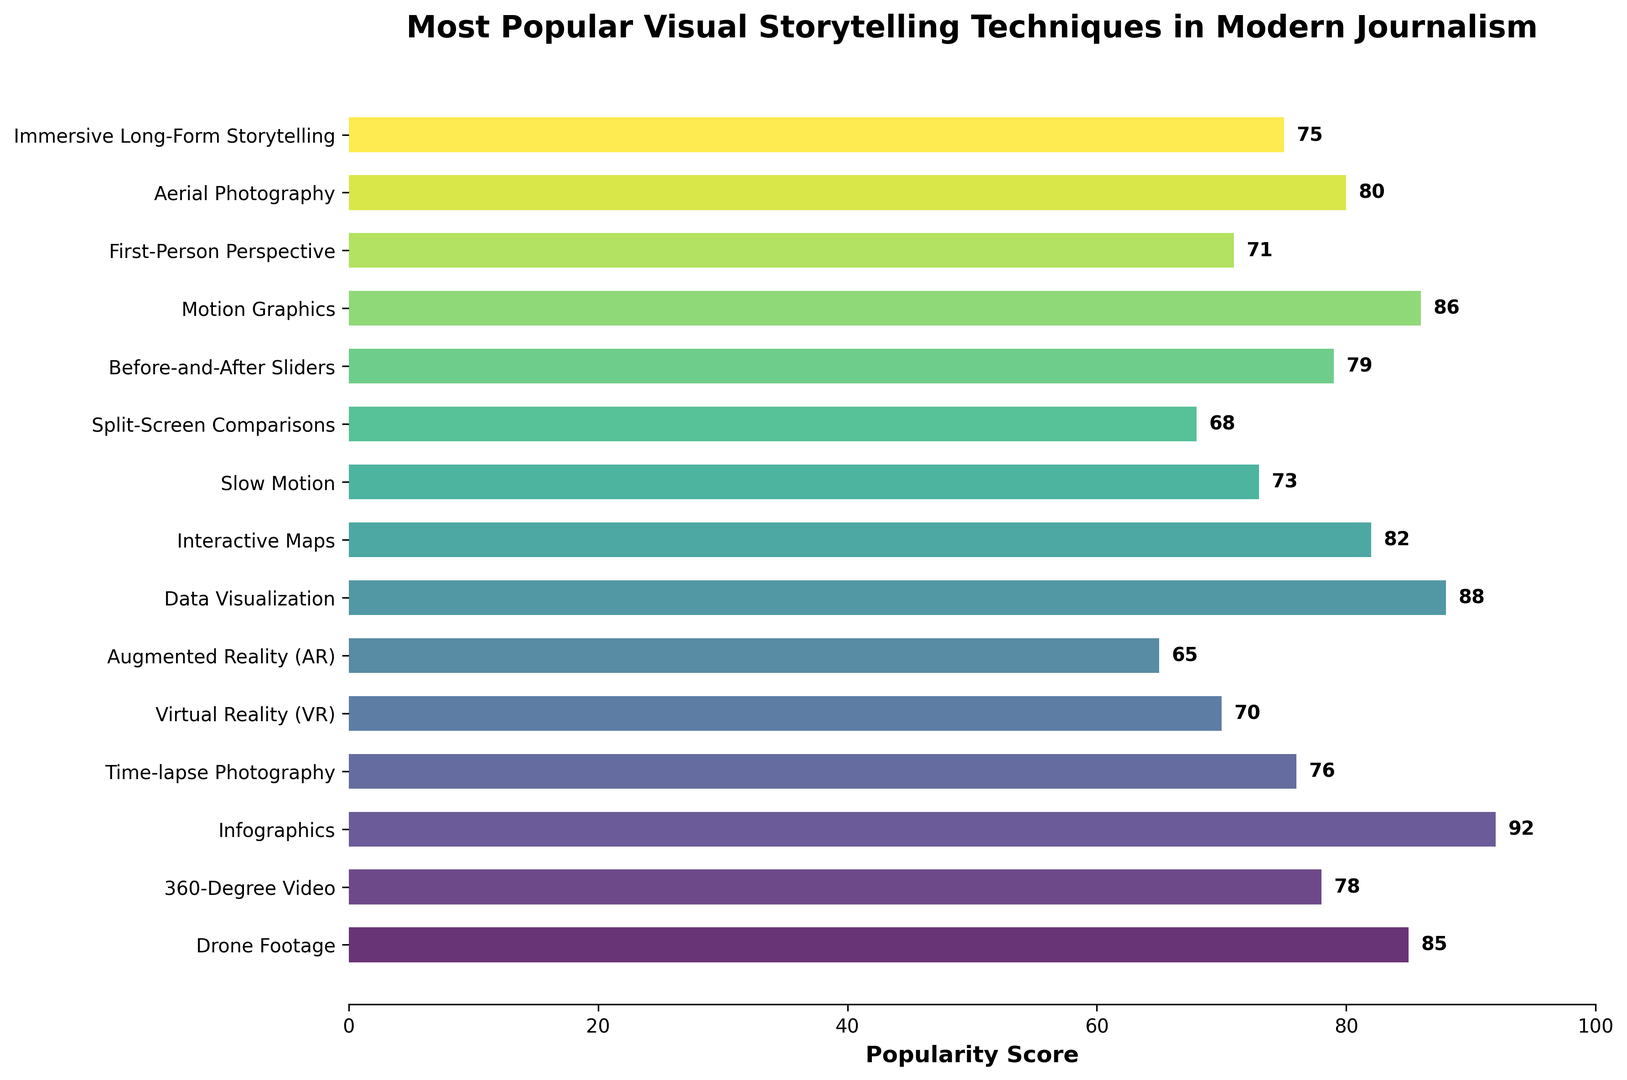Which visual storytelling technique has the highest popularity score? Look at the bar that reaches the farthest to the right. The title indicates it's a horizontal bar chart of popularity scores, and the technique with the longest bar is the one with the highest score.
Answer: Infographics What is the popularity score of Virtual Reality (VR)? Identify the bar labeled "Virtual Reality (VR)" and read the numerical value indicated next to it.
Answer: 70 How much higher is the popularity score of Data Visualization compared to Augmented Reality (AR)? Find the bars for Data Visualization and Augmented Reality (AR) and read their popularity scores. Subtract the score of Augmented Reality (AR) from Data Visualization. Data Visualization: 88, Augmented Reality (AR): 65. 88 - 65 = 23
Answer: 23 Which technique is more popular, Slow Motion or Split-Screen Comparisons? Locate the bars labeled "Slow Motion" and "Split-Screen Comparisons" and compare their lengths. Slow Motion has a popularity score of 73, while Split-Screen Comparisons has a score of 68. Slow Motion is more popular.
Answer: Slow Motion What is the average popularity score of the five most popular visual storytelling techniques? Identify the five longest bars and sum their popularity scores. Then divide by 5. Infographics (92), Motion Graphics (86), Drone Footage (85), Data Visualization (88), Interactive Maps (82). (92 + 86 + 85 + 88 + 82) / 5 = 86.6
Answer: 86.6 How many techniques have a popularity score greater than 80? Count the number of bars that extend past the numerical value of 80 on the x-axis. Four techniques have scores above 80: Drone Footage, Infographics, Data Visualization, and Interactive Maps.
Answer: 4 Which technique has the lowest popularity score? Observe the bar that is the shortest or closest to the left edge of the chart. The lowest popularity score corresponds to the shortest bar, which is Augmented Reality (AR) with a score of 65.
Answer: Augmented Reality (AR) What is the combined popularity score of the techniques that use "Photography" in their name? Locate the bars for "Drone Footage," "Time-lapse Photography," and "Aerial Photography" and sum their popularity scores. Drone Footage: 85, Time-lapse Photography: 76, Aerial Photography: 80. 85 + 76 + 80 = 241
Answer: 241 